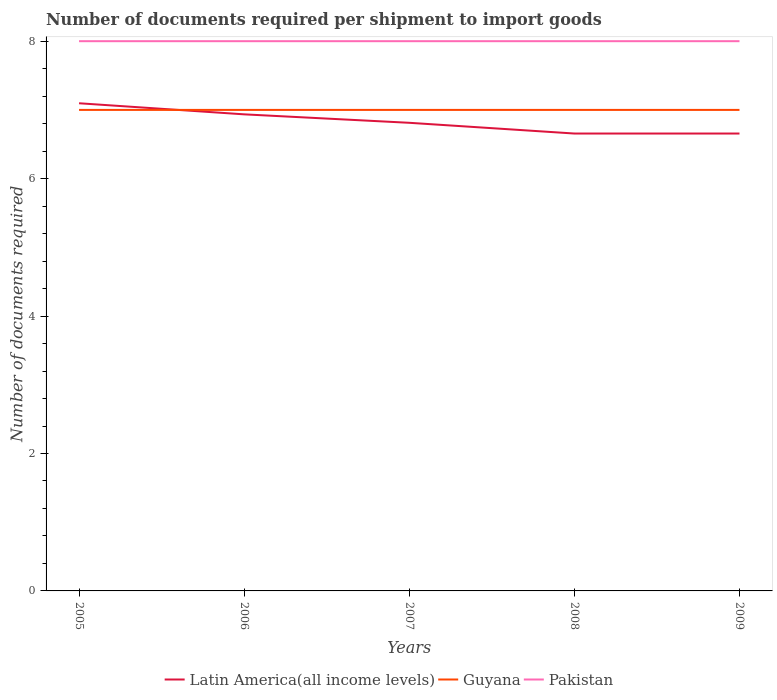How many different coloured lines are there?
Provide a succinct answer. 3. Does the line corresponding to Pakistan intersect with the line corresponding to Latin America(all income levels)?
Your answer should be compact. No. Is the number of lines equal to the number of legend labels?
Your answer should be compact. Yes. Across all years, what is the maximum number of documents required per shipment to import goods in Guyana?
Keep it short and to the point. 7. What is the total number of documents required per shipment to import goods in Pakistan in the graph?
Give a very brief answer. 0. What is the difference between the highest and the second highest number of documents required per shipment to import goods in Latin America(all income levels)?
Provide a succinct answer. 0.44. Is the number of documents required per shipment to import goods in Guyana strictly greater than the number of documents required per shipment to import goods in Latin America(all income levels) over the years?
Offer a terse response. No. How many years are there in the graph?
Provide a succinct answer. 5. What is the difference between two consecutive major ticks on the Y-axis?
Make the answer very short. 2. Does the graph contain any zero values?
Offer a very short reply. No. Where does the legend appear in the graph?
Your answer should be compact. Bottom center. What is the title of the graph?
Offer a terse response. Number of documents required per shipment to import goods. Does "Bulgaria" appear as one of the legend labels in the graph?
Offer a terse response. No. What is the label or title of the X-axis?
Ensure brevity in your answer.  Years. What is the label or title of the Y-axis?
Make the answer very short. Number of documents required. What is the Number of documents required of Latin America(all income levels) in 2005?
Provide a short and direct response. 7.1. What is the Number of documents required in Pakistan in 2005?
Make the answer very short. 8. What is the Number of documents required in Latin America(all income levels) in 2006?
Keep it short and to the point. 6.94. What is the Number of documents required of Latin America(all income levels) in 2007?
Make the answer very short. 6.81. What is the Number of documents required of Latin America(all income levels) in 2008?
Your answer should be very brief. 6.66. What is the Number of documents required in Latin America(all income levels) in 2009?
Your response must be concise. 6.66. Across all years, what is the maximum Number of documents required in Latin America(all income levels)?
Your response must be concise. 7.1. Across all years, what is the maximum Number of documents required of Guyana?
Make the answer very short. 7. Across all years, what is the maximum Number of documents required of Pakistan?
Ensure brevity in your answer.  8. Across all years, what is the minimum Number of documents required in Latin America(all income levels)?
Your response must be concise. 6.66. What is the total Number of documents required in Latin America(all income levels) in the graph?
Offer a terse response. 34.16. What is the total Number of documents required in Guyana in the graph?
Give a very brief answer. 35. What is the total Number of documents required in Pakistan in the graph?
Provide a succinct answer. 40. What is the difference between the Number of documents required of Latin America(all income levels) in 2005 and that in 2006?
Your answer should be very brief. 0.16. What is the difference between the Number of documents required of Latin America(all income levels) in 2005 and that in 2007?
Offer a very short reply. 0.28. What is the difference between the Number of documents required in Guyana in 2005 and that in 2007?
Offer a very short reply. 0. What is the difference between the Number of documents required in Latin America(all income levels) in 2005 and that in 2008?
Provide a short and direct response. 0.44. What is the difference between the Number of documents required of Guyana in 2005 and that in 2008?
Your answer should be very brief. 0. What is the difference between the Number of documents required of Latin America(all income levels) in 2005 and that in 2009?
Offer a terse response. 0.44. What is the difference between the Number of documents required in Guyana in 2005 and that in 2009?
Offer a very short reply. 0. What is the difference between the Number of documents required of Latin America(all income levels) in 2006 and that in 2007?
Offer a terse response. 0.12. What is the difference between the Number of documents required in Latin America(all income levels) in 2006 and that in 2008?
Make the answer very short. 0.28. What is the difference between the Number of documents required in Guyana in 2006 and that in 2008?
Your answer should be very brief. 0. What is the difference between the Number of documents required of Latin America(all income levels) in 2006 and that in 2009?
Ensure brevity in your answer.  0.28. What is the difference between the Number of documents required of Guyana in 2006 and that in 2009?
Keep it short and to the point. 0. What is the difference between the Number of documents required in Latin America(all income levels) in 2007 and that in 2008?
Provide a short and direct response. 0.16. What is the difference between the Number of documents required of Pakistan in 2007 and that in 2008?
Make the answer very short. 0. What is the difference between the Number of documents required of Latin America(all income levels) in 2007 and that in 2009?
Ensure brevity in your answer.  0.16. What is the difference between the Number of documents required of Guyana in 2007 and that in 2009?
Make the answer very short. 0. What is the difference between the Number of documents required in Guyana in 2008 and that in 2009?
Provide a succinct answer. 0. What is the difference between the Number of documents required of Latin America(all income levels) in 2005 and the Number of documents required of Guyana in 2006?
Offer a terse response. 0.1. What is the difference between the Number of documents required of Latin America(all income levels) in 2005 and the Number of documents required of Pakistan in 2006?
Offer a very short reply. -0.9. What is the difference between the Number of documents required in Latin America(all income levels) in 2005 and the Number of documents required in Guyana in 2007?
Give a very brief answer. 0.1. What is the difference between the Number of documents required of Latin America(all income levels) in 2005 and the Number of documents required of Pakistan in 2007?
Ensure brevity in your answer.  -0.9. What is the difference between the Number of documents required in Latin America(all income levels) in 2005 and the Number of documents required in Guyana in 2008?
Keep it short and to the point. 0.1. What is the difference between the Number of documents required of Latin America(all income levels) in 2005 and the Number of documents required of Pakistan in 2008?
Your answer should be compact. -0.9. What is the difference between the Number of documents required in Latin America(all income levels) in 2005 and the Number of documents required in Guyana in 2009?
Make the answer very short. 0.1. What is the difference between the Number of documents required of Latin America(all income levels) in 2005 and the Number of documents required of Pakistan in 2009?
Offer a very short reply. -0.9. What is the difference between the Number of documents required of Latin America(all income levels) in 2006 and the Number of documents required of Guyana in 2007?
Give a very brief answer. -0.06. What is the difference between the Number of documents required of Latin America(all income levels) in 2006 and the Number of documents required of Pakistan in 2007?
Keep it short and to the point. -1.06. What is the difference between the Number of documents required of Guyana in 2006 and the Number of documents required of Pakistan in 2007?
Give a very brief answer. -1. What is the difference between the Number of documents required in Latin America(all income levels) in 2006 and the Number of documents required in Guyana in 2008?
Keep it short and to the point. -0.06. What is the difference between the Number of documents required in Latin America(all income levels) in 2006 and the Number of documents required in Pakistan in 2008?
Your response must be concise. -1.06. What is the difference between the Number of documents required in Latin America(all income levels) in 2006 and the Number of documents required in Guyana in 2009?
Give a very brief answer. -0.06. What is the difference between the Number of documents required of Latin America(all income levels) in 2006 and the Number of documents required of Pakistan in 2009?
Provide a succinct answer. -1.06. What is the difference between the Number of documents required in Latin America(all income levels) in 2007 and the Number of documents required in Guyana in 2008?
Your response must be concise. -0.19. What is the difference between the Number of documents required of Latin America(all income levels) in 2007 and the Number of documents required of Pakistan in 2008?
Your response must be concise. -1.19. What is the difference between the Number of documents required of Latin America(all income levels) in 2007 and the Number of documents required of Guyana in 2009?
Make the answer very short. -0.19. What is the difference between the Number of documents required of Latin America(all income levels) in 2007 and the Number of documents required of Pakistan in 2009?
Your answer should be very brief. -1.19. What is the difference between the Number of documents required of Latin America(all income levels) in 2008 and the Number of documents required of Guyana in 2009?
Provide a short and direct response. -0.34. What is the difference between the Number of documents required in Latin America(all income levels) in 2008 and the Number of documents required in Pakistan in 2009?
Offer a terse response. -1.34. What is the average Number of documents required of Latin America(all income levels) per year?
Ensure brevity in your answer.  6.83. What is the average Number of documents required of Guyana per year?
Provide a succinct answer. 7. What is the average Number of documents required of Pakistan per year?
Provide a succinct answer. 8. In the year 2005, what is the difference between the Number of documents required in Latin America(all income levels) and Number of documents required in Guyana?
Offer a terse response. 0.1. In the year 2005, what is the difference between the Number of documents required in Latin America(all income levels) and Number of documents required in Pakistan?
Give a very brief answer. -0.9. In the year 2006, what is the difference between the Number of documents required in Latin America(all income levels) and Number of documents required in Guyana?
Keep it short and to the point. -0.06. In the year 2006, what is the difference between the Number of documents required of Latin America(all income levels) and Number of documents required of Pakistan?
Provide a short and direct response. -1.06. In the year 2007, what is the difference between the Number of documents required in Latin America(all income levels) and Number of documents required in Guyana?
Make the answer very short. -0.19. In the year 2007, what is the difference between the Number of documents required of Latin America(all income levels) and Number of documents required of Pakistan?
Make the answer very short. -1.19. In the year 2007, what is the difference between the Number of documents required in Guyana and Number of documents required in Pakistan?
Offer a terse response. -1. In the year 2008, what is the difference between the Number of documents required in Latin America(all income levels) and Number of documents required in Guyana?
Give a very brief answer. -0.34. In the year 2008, what is the difference between the Number of documents required of Latin America(all income levels) and Number of documents required of Pakistan?
Offer a terse response. -1.34. In the year 2008, what is the difference between the Number of documents required of Guyana and Number of documents required of Pakistan?
Your answer should be very brief. -1. In the year 2009, what is the difference between the Number of documents required of Latin America(all income levels) and Number of documents required of Guyana?
Offer a terse response. -0.34. In the year 2009, what is the difference between the Number of documents required of Latin America(all income levels) and Number of documents required of Pakistan?
Make the answer very short. -1.34. In the year 2009, what is the difference between the Number of documents required of Guyana and Number of documents required of Pakistan?
Offer a terse response. -1. What is the ratio of the Number of documents required in Latin America(all income levels) in 2005 to that in 2006?
Keep it short and to the point. 1.02. What is the ratio of the Number of documents required in Guyana in 2005 to that in 2006?
Provide a succinct answer. 1. What is the ratio of the Number of documents required of Latin America(all income levels) in 2005 to that in 2007?
Give a very brief answer. 1.04. What is the ratio of the Number of documents required in Guyana in 2005 to that in 2007?
Your answer should be very brief. 1. What is the ratio of the Number of documents required of Pakistan in 2005 to that in 2007?
Offer a very short reply. 1. What is the ratio of the Number of documents required of Latin America(all income levels) in 2005 to that in 2008?
Your answer should be very brief. 1.07. What is the ratio of the Number of documents required of Guyana in 2005 to that in 2008?
Offer a terse response. 1. What is the ratio of the Number of documents required in Latin America(all income levels) in 2005 to that in 2009?
Offer a terse response. 1.07. What is the ratio of the Number of documents required of Latin America(all income levels) in 2006 to that in 2007?
Offer a terse response. 1.02. What is the ratio of the Number of documents required in Pakistan in 2006 to that in 2007?
Offer a terse response. 1. What is the ratio of the Number of documents required of Latin America(all income levels) in 2006 to that in 2008?
Offer a very short reply. 1.04. What is the ratio of the Number of documents required in Guyana in 2006 to that in 2008?
Your response must be concise. 1. What is the ratio of the Number of documents required in Pakistan in 2006 to that in 2008?
Ensure brevity in your answer.  1. What is the ratio of the Number of documents required in Latin America(all income levels) in 2006 to that in 2009?
Offer a terse response. 1.04. What is the ratio of the Number of documents required of Latin America(all income levels) in 2007 to that in 2008?
Your answer should be compact. 1.02. What is the ratio of the Number of documents required in Latin America(all income levels) in 2007 to that in 2009?
Your answer should be very brief. 1.02. What is the ratio of the Number of documents required in Guyana in 2007 to that in 2009?
Your answer should be compact. 1. What is the ratio of the Number of documents required of Guyana in 2008 to that in 2009?
Give a very brief answer. 1. What is the difference between the highest and the second highest Number of documents required in Latin America(all income levels)?
Your answer should be compact. 0.16. What is the difference between the highest and the lowest Number of documents required of Latin America(all income levels)?
Give a very brief answer. 0.44. What is the difference between the highest and the lowest Number of documents required in Guyana?
Your answer should be very brief. 0. 